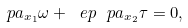Convert formula to latex. <formula><loc_0><loc_0><loc_500><loc_500>\ p a _ { x _ { 1 } } \omega + \ e p \ p a _ { x _ { 2 } } \tau = 0 ,</formula> 